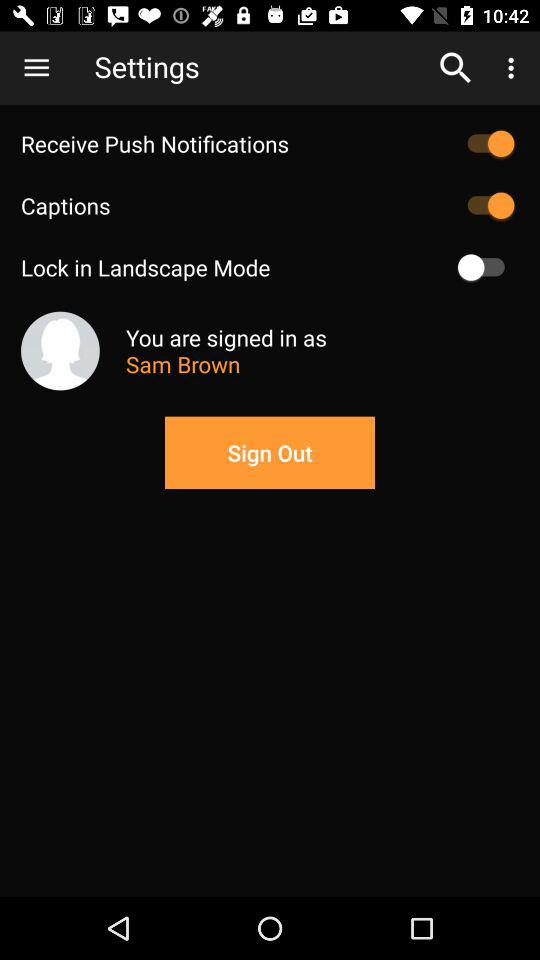What is the name of the user? The name of the user is Sam Brown. 